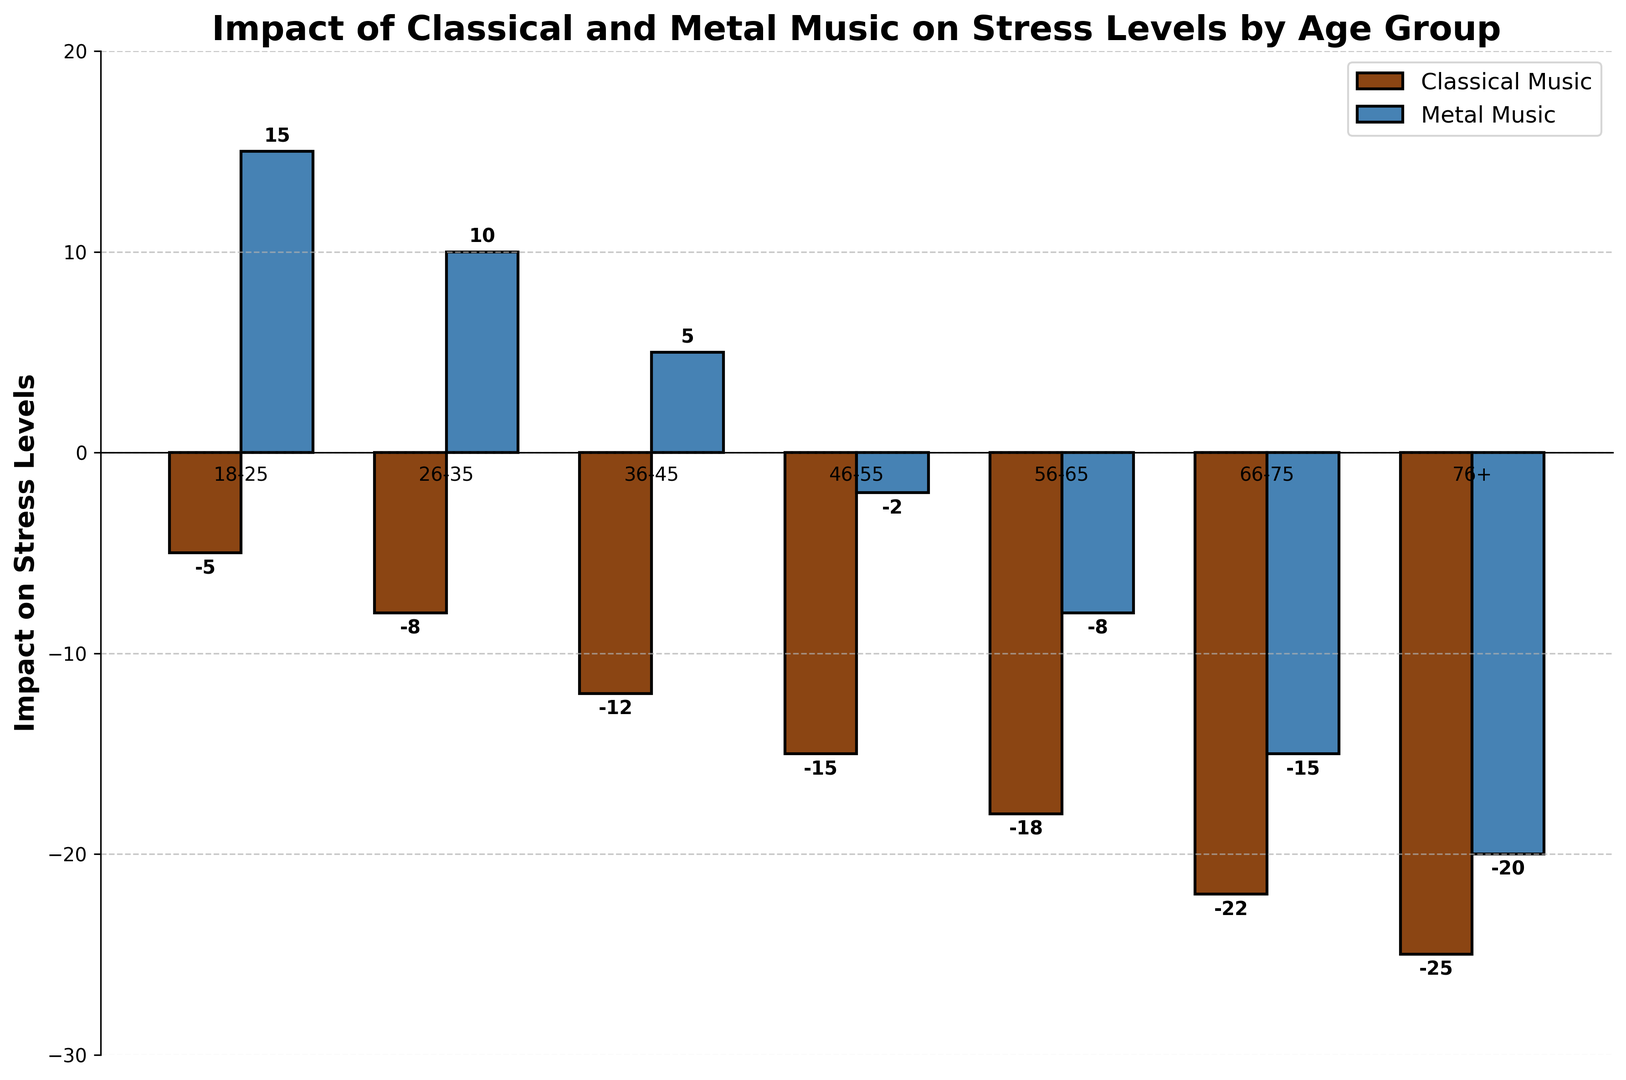Which age group experiences the greatest reduction in stress levels from classical music? By examining the height of the bars representing the impact of classical music, the most negative value indicating the greatest reduction is seen in the 76+ age group at -25.
Answer: 76+ How does the impact of metal music on stress levels for the 18-25 age group compare to that of the 66-75 age group? Looking at the heights of the bars, the impact for the 18-25 age group (15) is higher compared to the 66-75 age group (-15).
Answer: Higher Which genre shows a positive impact on stress levels for the 26-35 age group? The bar representing metal music for the 26-35 age group is above zero, indicating a positive impact (10), while the classical music impact is below zero (-8).
Answer: Metal music What is the combined impact of classical music and metal music on stress levels for the 46-55 age group? Sum the values for this age group (-15 for classical music and -2 for metal music), resulting in a combined impact of -17.
Answer: -17 What is the average impact of classical music across all age groups? Sum the impacts for classical music across all age groups and divide by the number of age groups. (-5 + -8 + -12 + -15 + -18 + -22 + -25) / 7 = -15
Answer: -15 For the 56-65 age group, which genre has a less negative impact on stress levels? Compare the heights of the bars, with classical music at -18 and metal music at -8, indicating that metal music has a less negative impact.
Answer: Metal music Does the impact of metal music on stress levels remain positive for any age group over 45? Look for positive values in the metal music bars for age groups over 45. Only age groups 46-55 (-2), 56-65 (-8), 66-75 (-15), and 76+ (-20) have bars below zero.
Answer: No What trend is visible regarding the impact of classical music on stress levels as the age groups progress from 18-25 to 76+? The heights of the bars for classical music decrease from -5 to -25, indicating a progressively stronger negative impact on stress levels.
Answer: Increasingly negative 